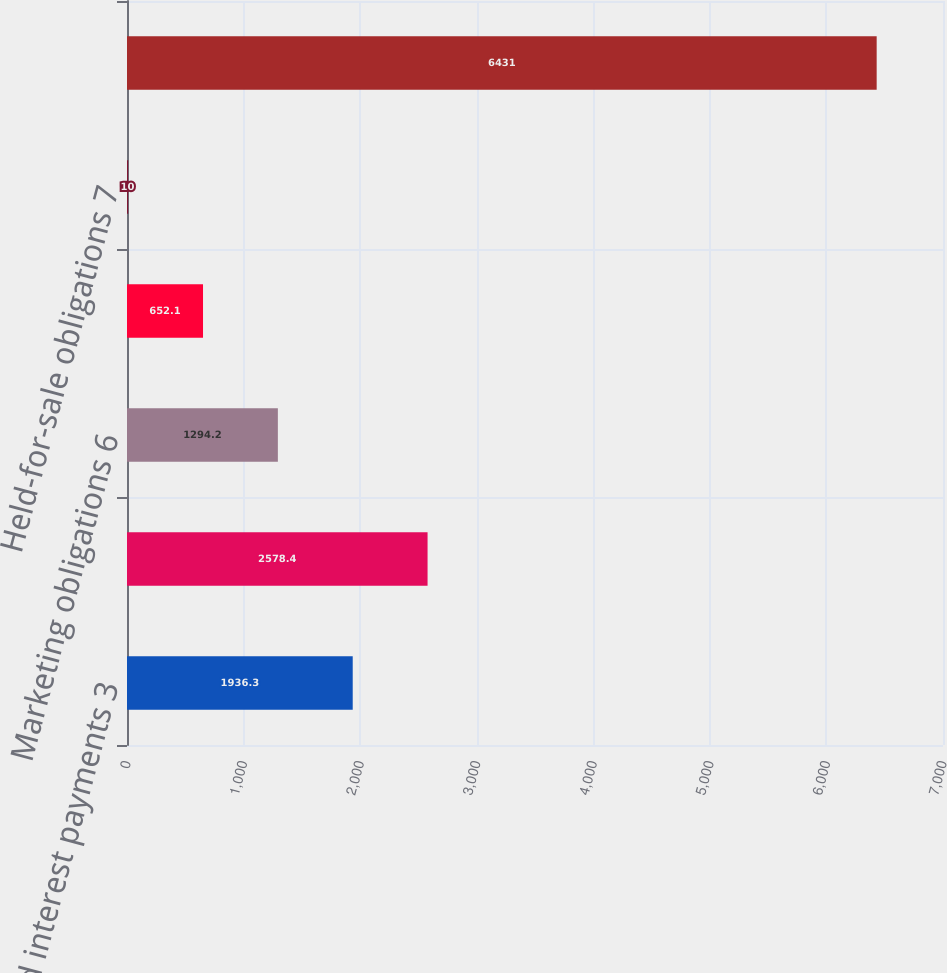Convert chart to OTSL. <chart><loc_0><loc_0><loc_500><loc_500><bar_chart><fcel>Estimated interest payments 3<fcel>Purchase obligations 5<fcel>Marketing obligations 6<fcel>Lease obligations<fcel>Held-for-sale obligations 7<fcel>Total contractual obligations<nl><fcel>1936.3<fcel>2578.4<fcel>1294.2<fcel>652.1<fcel>10<fcel>6431<nl></chart> 